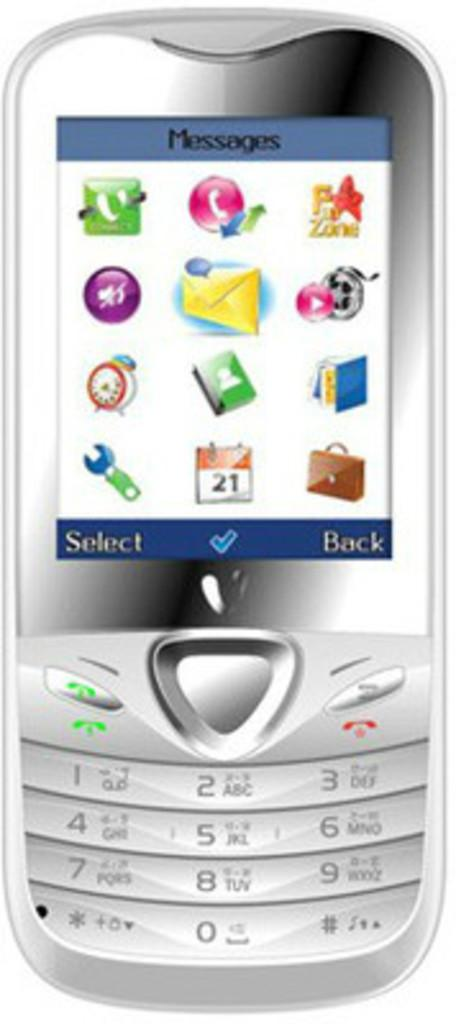<image>
Provide a brief description of the given image. A silver cell phone that says messages on the screen. 